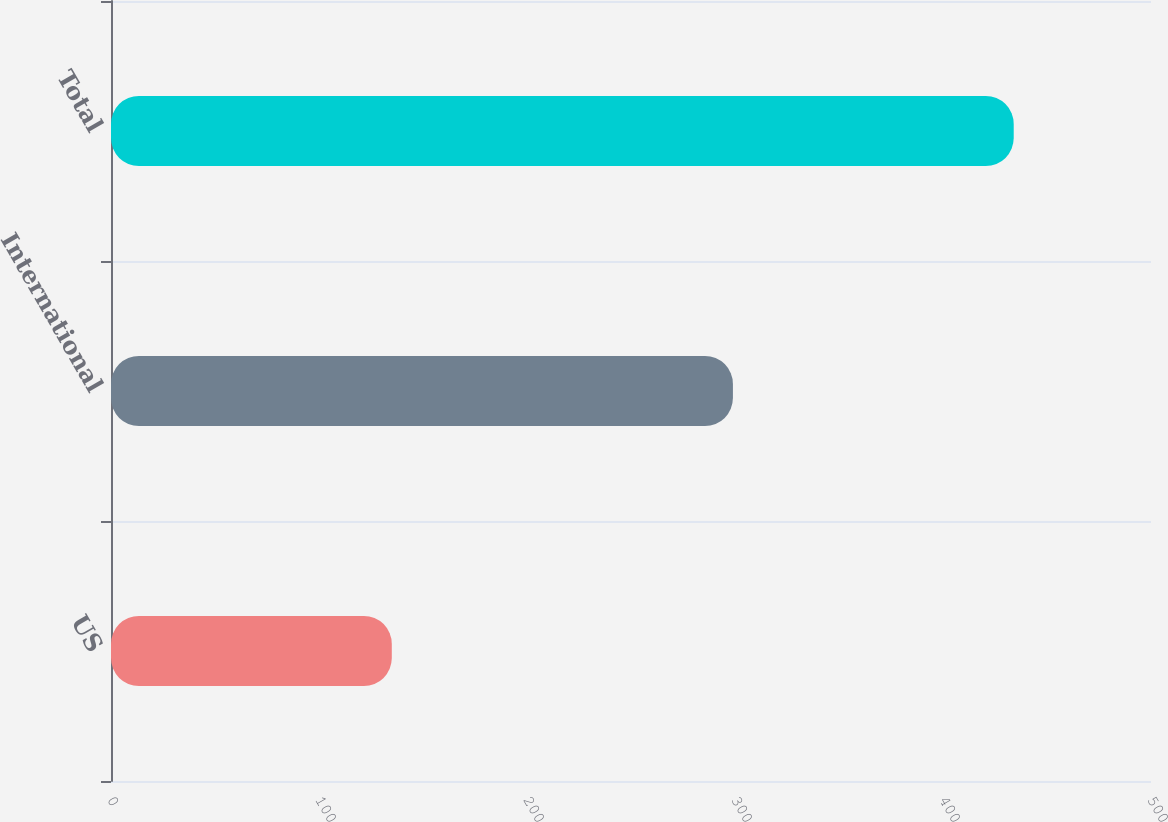<chart> <loc_0><loc_0><loc_500><loc_500><bar_chart><fcel>US<fcel>International<fcel>Total<nl><fcel>135<fcel>299<fcel>434<nl></chart> 